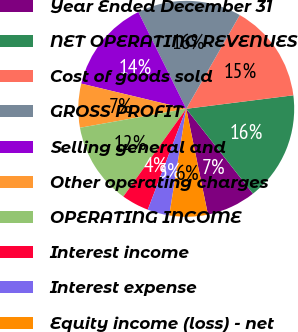Convert chart. <chart><loc_0><loc_0><loc_500><loc_500><pie_chart><fcel>Year Ended December 31<fcel>NET OPERATING REVENUES<fcel>Cost of goods sold<fcel>GROSS PROFIT<fcel>Selling general and<fcel>Other operating charges<fcel>OPERATING INCOME<fcel>Interest income<fcel>Interest expense<fcel>Equity income (loss) - net<nl><fcel>7.38%<fcel>16.39%<fcel>14.75%<fcel>15.57%<fcel>13.93%<fcel>6.56%<fcel>12.29%<fcel>4.1%<fcel>3.28%<fcel>5.74%<nl></chart> 